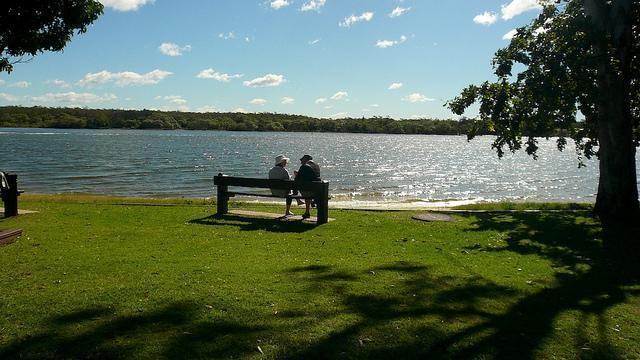How many benches are in the scene?
Give a very brief answer. 1. How many bottles of soap are by the sinks?
Give a very brief answer. 0. 